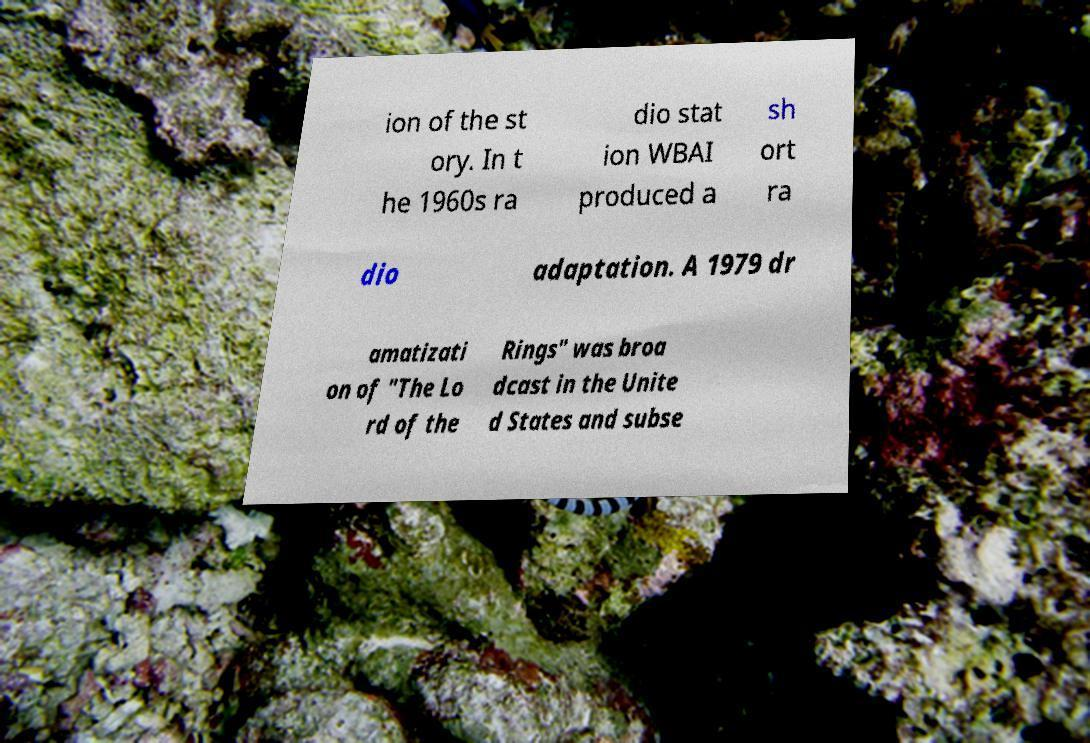What messages or text are displayed in this image? I need them in a readable, typed format. ion of the st ory. In t he 1960s ra dio stat ion WBAI produced a sh ort ra dio adaptation. A 1979 dr amatizati on of "The Lo rd of the Rings" was broa dcast in the Unite d States and subse 